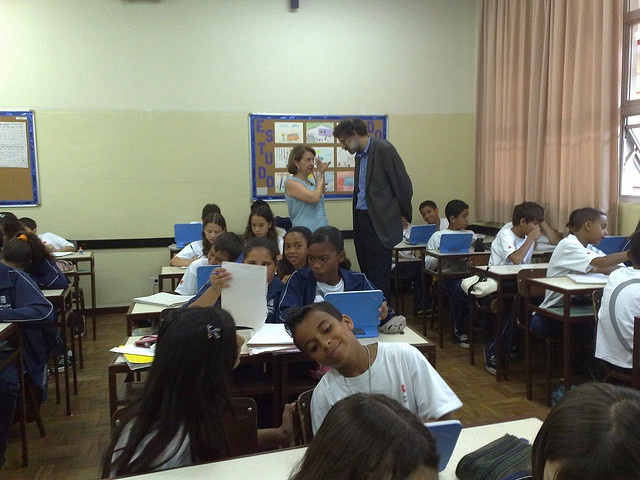Describe the objects in this image and their specific colors. I can see people in beige, black, darkgray, gray, and lightgray tones, people in beige, black, gray, and darkgray tones, people in beige, darkgray, black, lightgray, and maroon tones, people in beige, black, and gray tones, and people in beige, black, and gray tones in this image. 